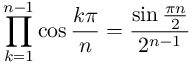<formula> <loc_0><loc_0><loc_500><loc_500>\prod _ { k = 1 } ^ { n - 1 } \cos { \frac { k \pi } { n } } = { \frac { \sin { \frac { \pi n } { 2 } } } { 2 ^ { n - 1 } } }</formula> 